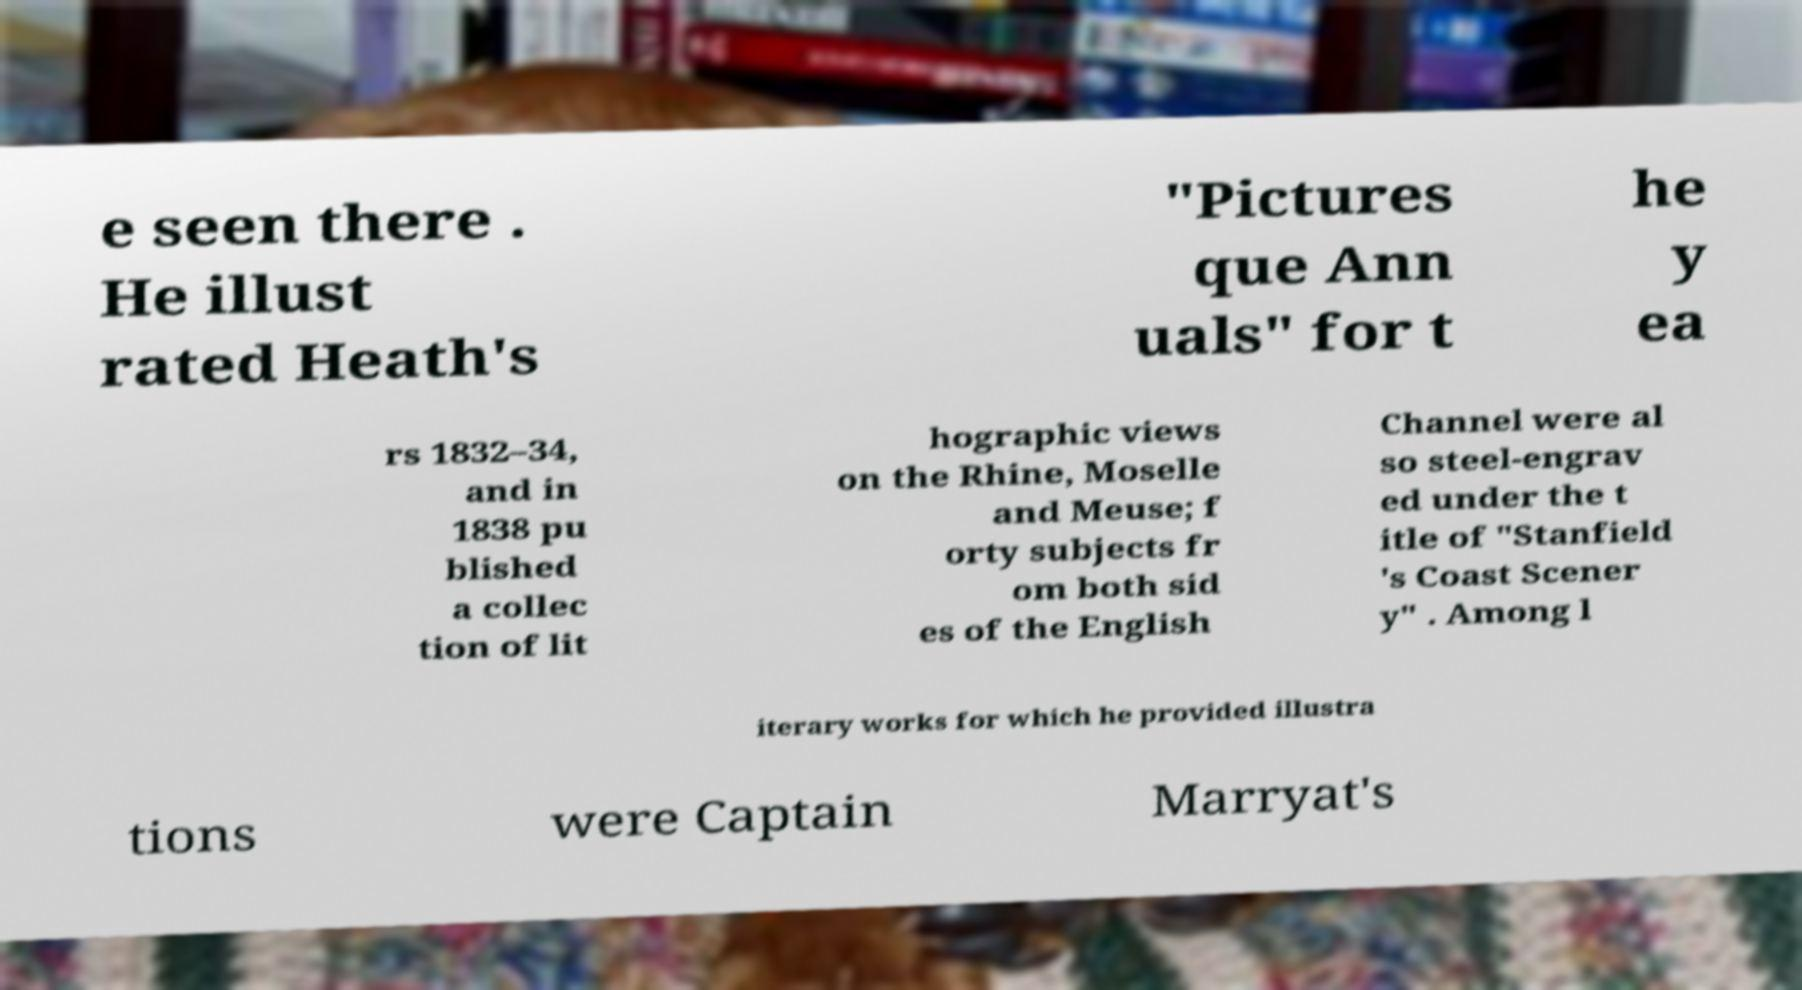There's text embedded in this image that I need extracted. Can you transcribe it verbatim? e seen there . He illust rated Heath's "Pictures que Ann uals" for t he y ea rs 1832–34, and in 1838 pu blished a collec tion of lit hographic views on the Rhine, Moselle and Meuse; f orty subjects fr om both sid es of the English Channel were al so steel-engrav ed under the t itle of "Stanfield 's Coast Scener y" . Among l iterary works for which he provided illustra tions were Captain Marryat's 